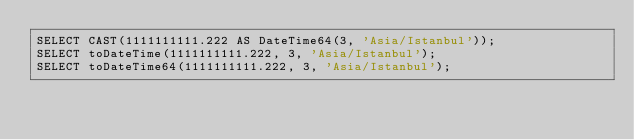<code> <loc_0><loc_0><loc_500><loc_500><_SQL_>SELECT CAST(1111111111.222 AS DateTime64(3, 'Asia/Istanbul'));
SELECT toDateTime(1111111111.222, 3, 'Asia/Istanbul');
SELECT toDateTime64(1111111111.222, 3, 'Asia/Istanbul');
</code> 